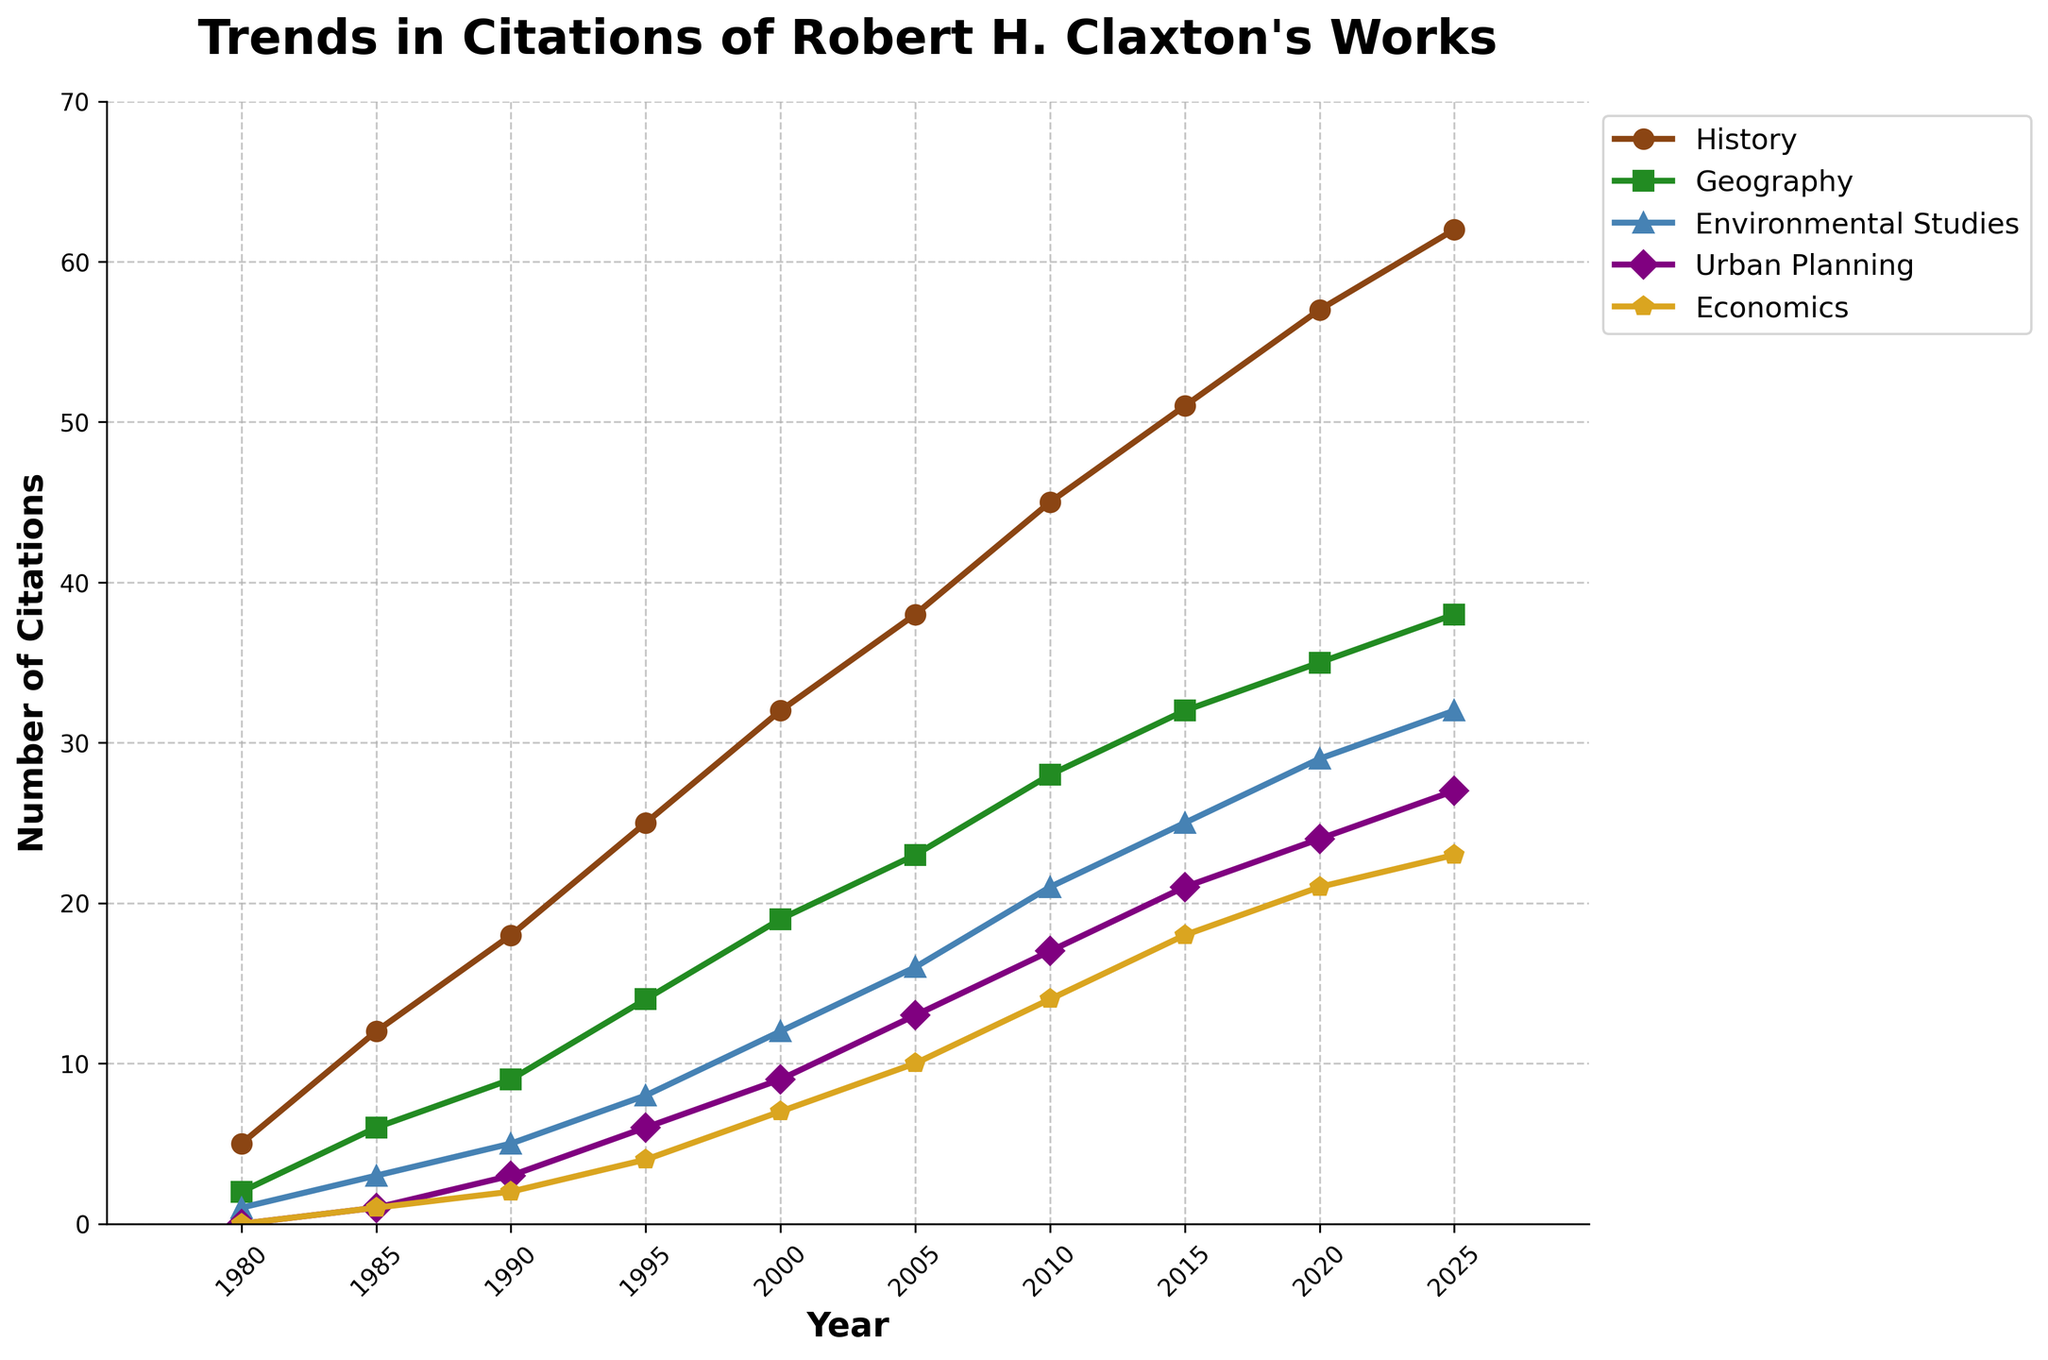What is the trend in the number of citations for Robert H. Claxton's works in History from 1980 to 2025? Looking at the line corresponding to History, you can see a steady increase in the number of citations from 1980 to 2025. It starts at 5 citations in 1980 and rises progressively to 62 citations in 2025.
Answer: Steady increase In which year does Geography surpass Environmental Studies in the number of citations? First, identify the years and number of citations for Geography and Environmental Studies. Geography surpasses Environmental Studies between 2000 and 2005, where Geography has 23 citations and Environmental Studies has 16.
Answer: 2005 What is the average number of citations for Urban Planning from 1980 to 2025? Add the citation numbers for Urban Planning from 1980 to 2025 and divide by the count of years. Sum is 0 + 1 + 3 + 6 + 9 + 13 + 17 + 21 + 24 + 27 = 121, and average is 121 / 10 = 12.1.
Answer: 12.1 How does the citation trend in Economics compare to that in Environmental Studies over the years? Both trends show an increase, but Economics starts lower at 0 citations in 1980 and rises to 23 in 2025, whereas Environmental Studies starts at 1 in 1980 and reaches 32 in 2025. Environmental Studies has more citations overall.
Answer: Environmental Studies has more citations Which discipline has the highest number of citations in 2025 and what is that number? Look at the 2025 data for all disciplines: History has 62, Geography has 38, Environmental Studies has 32, Urban Planning has 27, Economics has 23. History has the highest.
Answer: History, 62 By how much did the citations in Geography increase from 2000 to 2020? Subtract the citations in 2000 from those in 2020 for Geography. Calculations are 35 - 19 = 16.
Answer: 16 Between 1990 and 2000, which discipline saw the greatest absolute increase in citations? Calculate the absolute increase for each discipline between 1990 and 2000: History (32-18 = 14), Geography (19-9 = 10), Environmental Studies (12-5 = 7), Urban Planning (9-3 = 6), Economics (7-2 = 5). History has the greatest.
Answer: History What is the difference in the number of citations between history and economics in 2020? Subtract Economics citations from History citations in 2020: 57 - 21 = 36.
Answer: 36 Identify the discipline with the slowest growth rate from 1980 to 2025. Calculate the total increase for each discipline: History (62-5 = 57), Geography (38-2 = 36), Environmental Studies (32-1 = 31), Urban Planning (27-0 = 27), Economics (23-0 = 23). Economics has the slowest growth rate.
Answer: Economics Which year showed equal citations (or the closest to equal citations) for Urban Planning and Economics? Compare the citations year by year: 2005 shows 13 (Urban Planning) vs. 10 (Economics) and 2025 shows 27 (Urban Planning) vs. 23 (Economics). 2025 is closer with a difference of 4.
Answer: 2025 